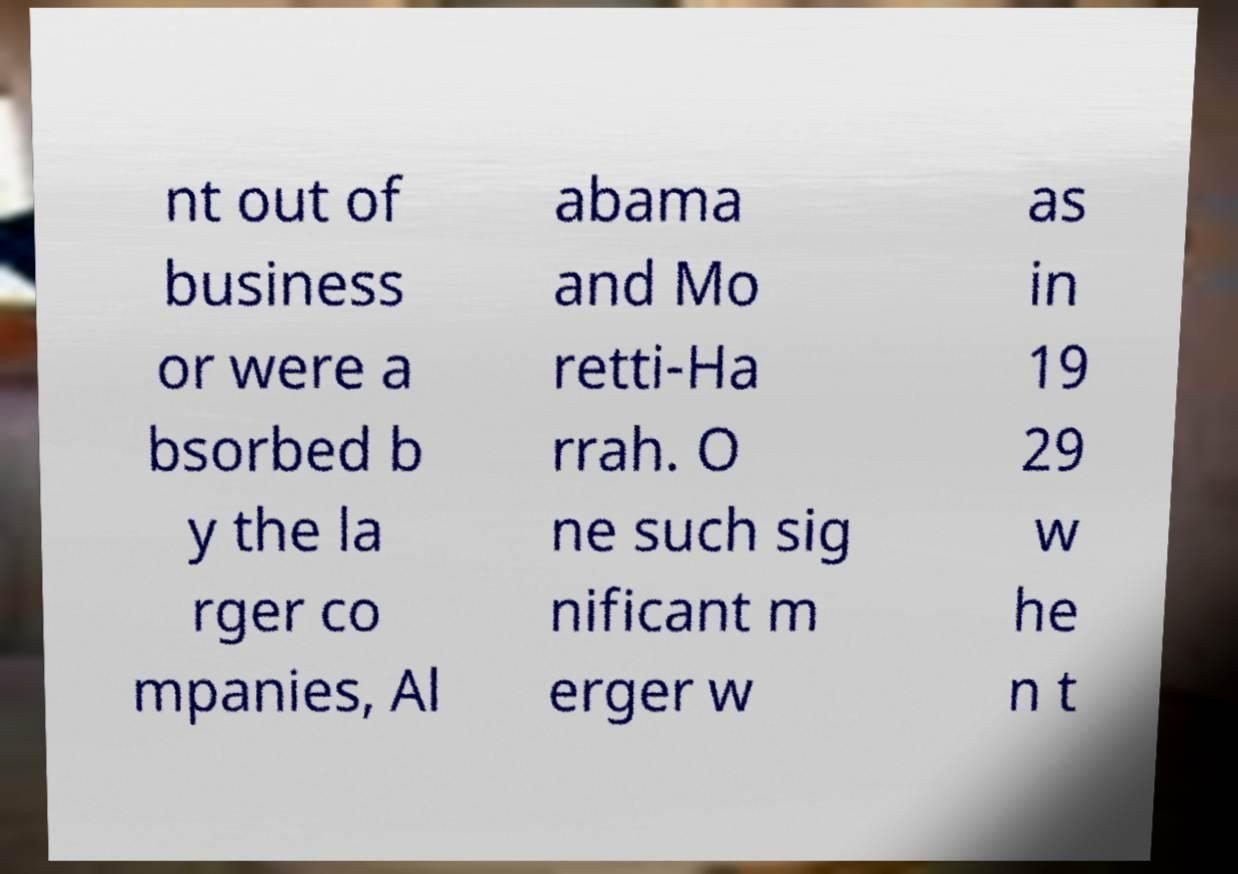For documentation purposes, I need the text within this image transcribed. Could you provide that? nt out of business or were a bsorbed b y the la rger co mpanies, Al abama and Mo retti-Ha rrah. O ne such sig nificant m erger w as in 19 29 w he n t 